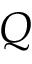<formula> <loc_0><loc_0><loc_500><loc_500>Q</formula> 